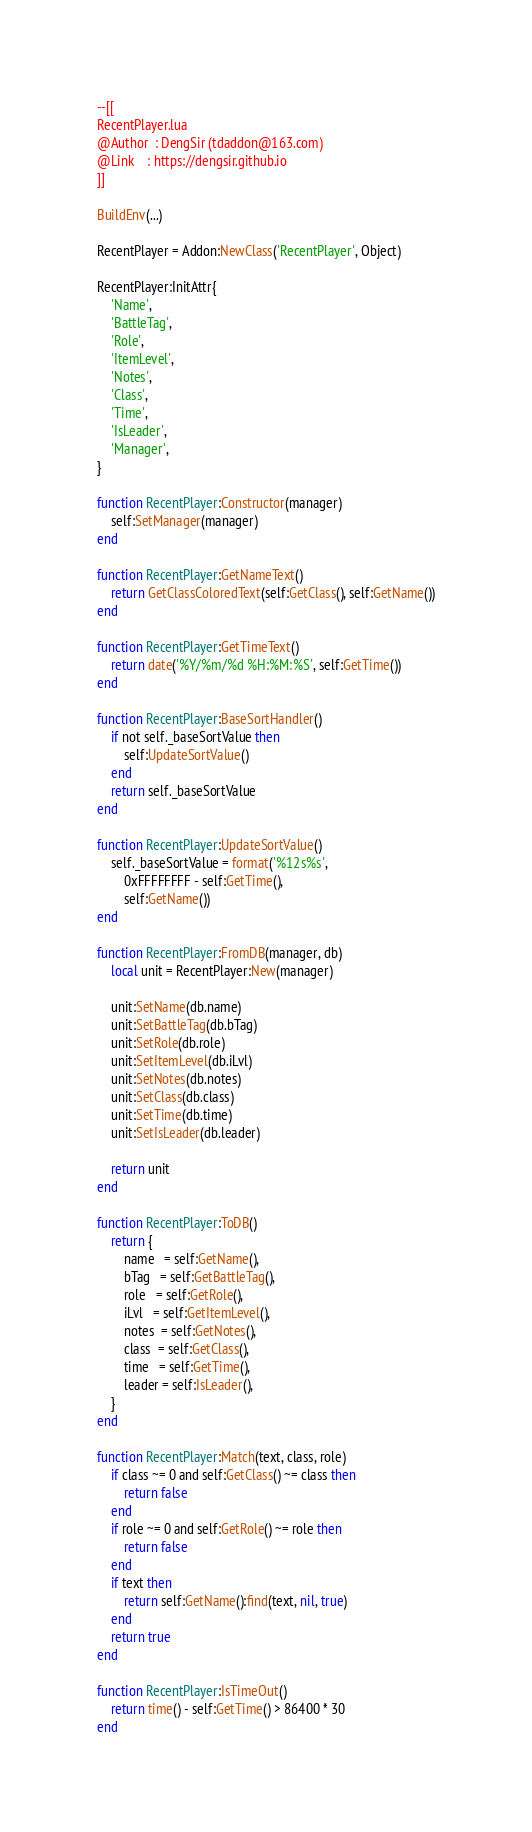<code> <loc_0><loc_0><loc_500><loc_500><_Lua_>--[[
RecentPlayer.lua
@Author  : DengSir (tdaddon@163.com)
@Link    : https://dengsir.github.io
]]

BuildEnv(...)

RecentPlayer = Addon:NewClass('RecentPlayer', Object)

RecentPlayer:InitAttr{
    'Name',
    'BattleTag',
    'Role',
    'ItemLevel',
    'Notes',
    'Class',
    'Time',
    'IsLeader',
    'Manager',
}

function RecentPlayer:Constructor(manager)
    self:SetManager(manager)
end

function RecentPlayer:GetNameText()
    return GetClassColoredText(self:GetClass(), self:GetName())
end

function RecentPlayer:GetTimeText()
    return date('%Y/%m/%d %H:%M:%S', self:GetTime())
end

function RecentPlayer:BaseSortHandler()
    if not self._baseSortValue then
        self:UpdateSortValue()
    end
    return self._baseSortValue
end

function RecentPlayer:UpdateSortValue()
    self._baseSortValue = format('%12s%s',
        0xFFFFFFFF - self:GetTime(),
        self:GetName())
end

function RecentPlayer:FromDB(manager, db)
    local unit = RecentPlayer:New(manager)

    unit:SetName(db.name)
    unit:SetBattleTag(db.bTag)
    unit:SetRole(db.role)
    unit:SetItemLevel(db.iLvl)
    unit:SetNotes(db.notes)
    unit:SetClass(db.class)
    unit:SetTime(db.time)
    unit:SetIsLeader(db.leader)

    return unit
end

function RecentPlayer:ToDB()
    return {
        name   = self:GetName(),
        bTag   = self:GetBattleTag(),
        role   = self:GetRole(),
        iLvl   = self:GetItemLevel(),
        notes  = self:GetNotes(),
        class  = self:GetClass(),
        time   = self:GetTime(),
        leader = self:IsLeader(),
    }
end

function RecentPlayer:Match(text, class, role)
    if class ~= 0 and self:GetClass() ~= class then
        return false
    end
    if role ~= 0 and self:GetRole() ~= role then
        return false
    end
    if text then
        return self:GetName():find(text, nil, true)
    end
    return true
end

function RecentPlayer:IsTimeOut()
    return time() - self:GetTime() > 86400 * 30
end
</code> 